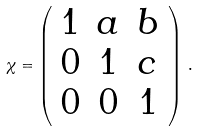Convert formula to latex. <formula><loc_0><loc_0><loc_500><loc_500>\chi = \left ( \begin{array} { c c c } 1 & a & b \\ 0 & 1 & c \\ 0 & 0 & 1 \end{array} \right ) \, .</formula> 